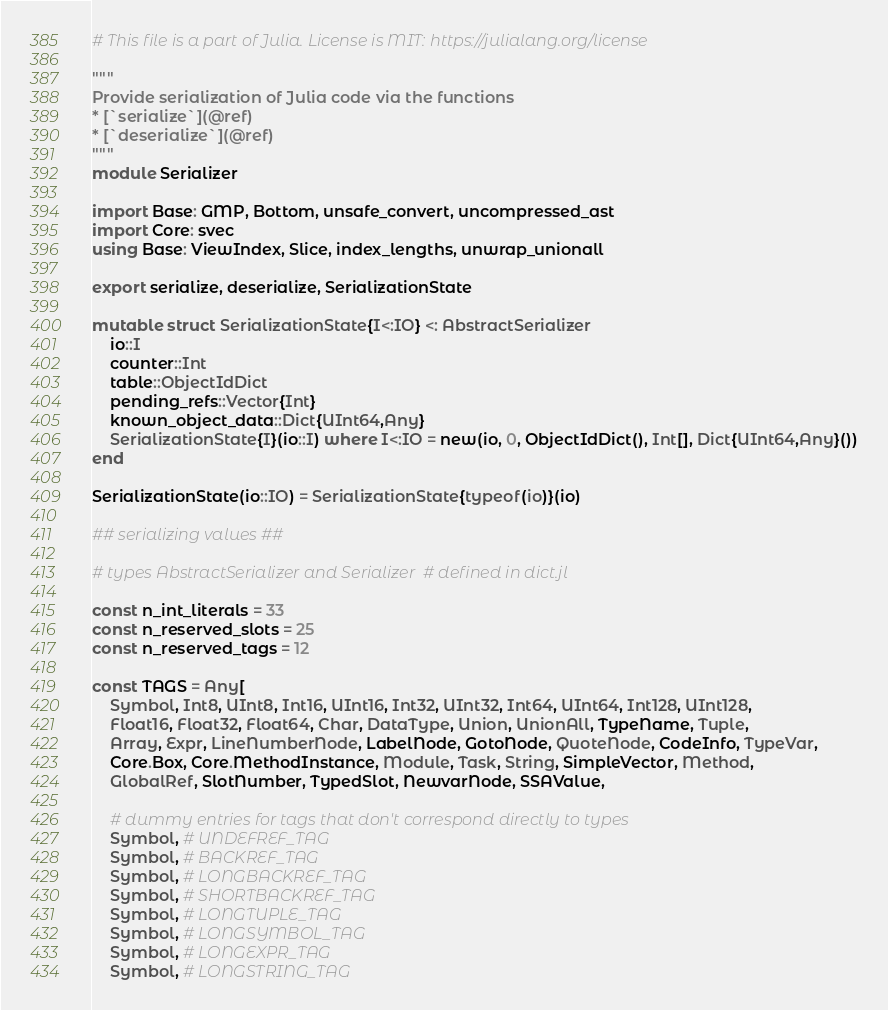Convert code to text. <code><loc_0><loc_0><loc_500><loc_500><_Julia_># This file is a part of Julia. License is MIT: https://julialang.org/license

"""
Provide serialization of Julia code via the functions
* [`serialize`](@ref)
* [`deserialize`](@ref)
"""
module Serializer

import Base: GMP, Bottom, unsafe_convert, uncompressed_ast
import Core: svec
using Base: ViewIndex, Slice, index_lengths, unwrap_unionall

export serialize, deserialize, SerializationState

mutable struct SerializationState{I<:IO} <: AbstractSerializer
    io::I
    counter::Int
    table::ObjectIdDict
    pending_refs::Vector{Int}
    known_object_data::Dict{UInt64,Any}
    SerializationState{I}(io::I) where I<:IO = new(io, 0, ObjectIdDict(), Int[], Dict{UInt64,Any}())
end

SerializationState(io::IO) = SerializationState{typeof(io)}(io)

## serializing values ##

# types AbstractSerializer and Serializer  # defined in dict.jl

const n_int_literals = 33
const n_reserved_slots = 25
const n_reserved_tags = 12

const TAGS = Any[
    Symbol, Int8, UInt8, Int16, UInt16, Int32, UInt32, Int64, UInt64, Int128, UInt128,
    Float16, Float32, Float64, Char, DataType, Union, UnionAll, TypeName, Tuple,
    Array, Expr, LineNumberNode, LabelNode, GotoNode, QuoteNode, CodeInfo, TypeVar,
    Core.Box, Core.MethodInstance, Module, Task, String, SimpleVector, Method,
    GlobalRef, SlotNumber, TypedSlot, NewvarNode, SSAValue,

    # dummy entries for tags that don't correspond directly to types
    Symbol, # UNDEFREF_TAG
    Symbol, # BACKREF_TAG
    Symbol, # LONGBACKREF_TAG
    Symbol, # SHORTBACKREF_TAG
    Symbol, # LONGTUPLE_TAG
    Symbol, # LONGSYMBOL_TAG
    Symbol, # LONGEXPR_TAG
    Symbol, # LONGSTRING_TAG</code> 